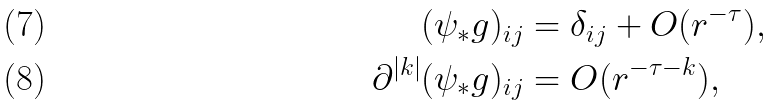Convert formula to latex. <formula><loc_0><loc_0><loc_500><loc_500>( \psi _ { * } g ) _ { i j } & = \delta _ { i j } + O ( r ^ { - \tau } ) , \\ \ \partial ^ { | k | } ( \psi _ { * } g ) _ { i j } & = O ( r ^ { - \tau - k } ) ,</formula> 